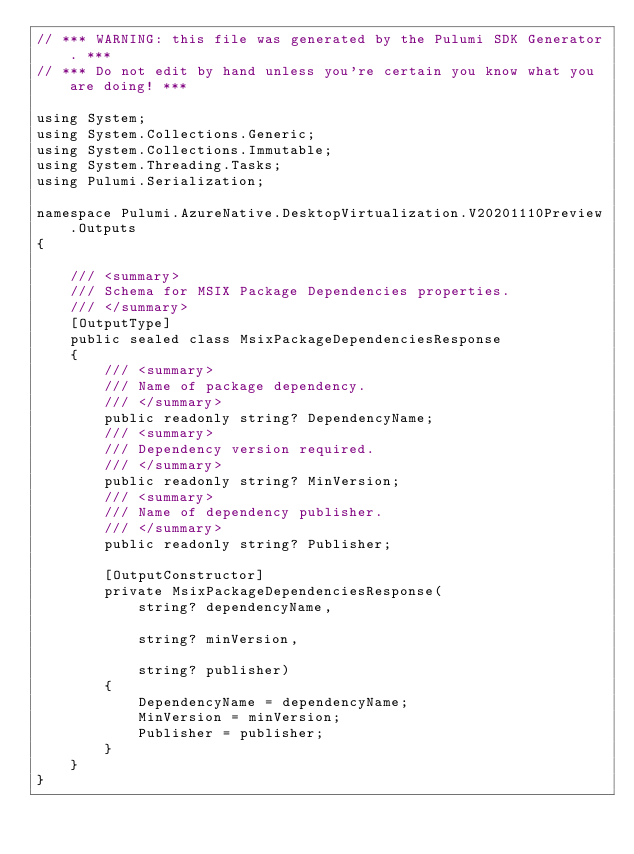<code> <loc_0><loc_0><loc_500><loc_500><_C#_>// *** WARNING: this file was generated by the Pulumi SDK Generator. ***
// *** Do not edit by hand unless you're certain you know what you are doing! ***

using System;
using System.Collections.Generic;
using System.Collections.Immutable;
using System.Threading.Tasks;
using Pulumi.Serialization;

namespace Pulumi.AzureNative.DesktopVirtualization.V20201110Preview.Outputs
{

    /// <summary>
    /// Schema for MSIX Package Dependencies properties.
    /// </summary>
    [OutputType]
    public sealed class MsixPackageDependenciesResponse
    {
        /// <summary>
        /// Name of package dependency.
        /// </summary>
        public readonly string? DependencyName;
        /// <summary>
        /// Dependency version required.
        /// </summary>
        public readonly string? MinVersion;
        /// <summary>
        /// Name of dependency publisher.
        /// </summary>
        public readonly string? Publisher;

        [OutputConstructor]
        private MsixPackageDependenciesResponse(
            string? dependencyName,

            string? minVersion,

            string? publisher)
        {
            DependencyName = dependencyName;
            MinVersion = minVersion;
            Publisher = publisher;
        }
    }
}
</code> 